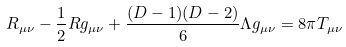Convert formula to latex. <formula><loc_0><loc_0><loc_500><loc_500>R _ { \mu \nu } - \frac { 1 } { 2 } { R } g _ { \mu \nu } + \frac { ( D - 1 ) ( D - 2 ) } { 6 } \Lambda g _ { \mu \nu } = 8 \pi { T } _ { \mu \nu }</formula> 